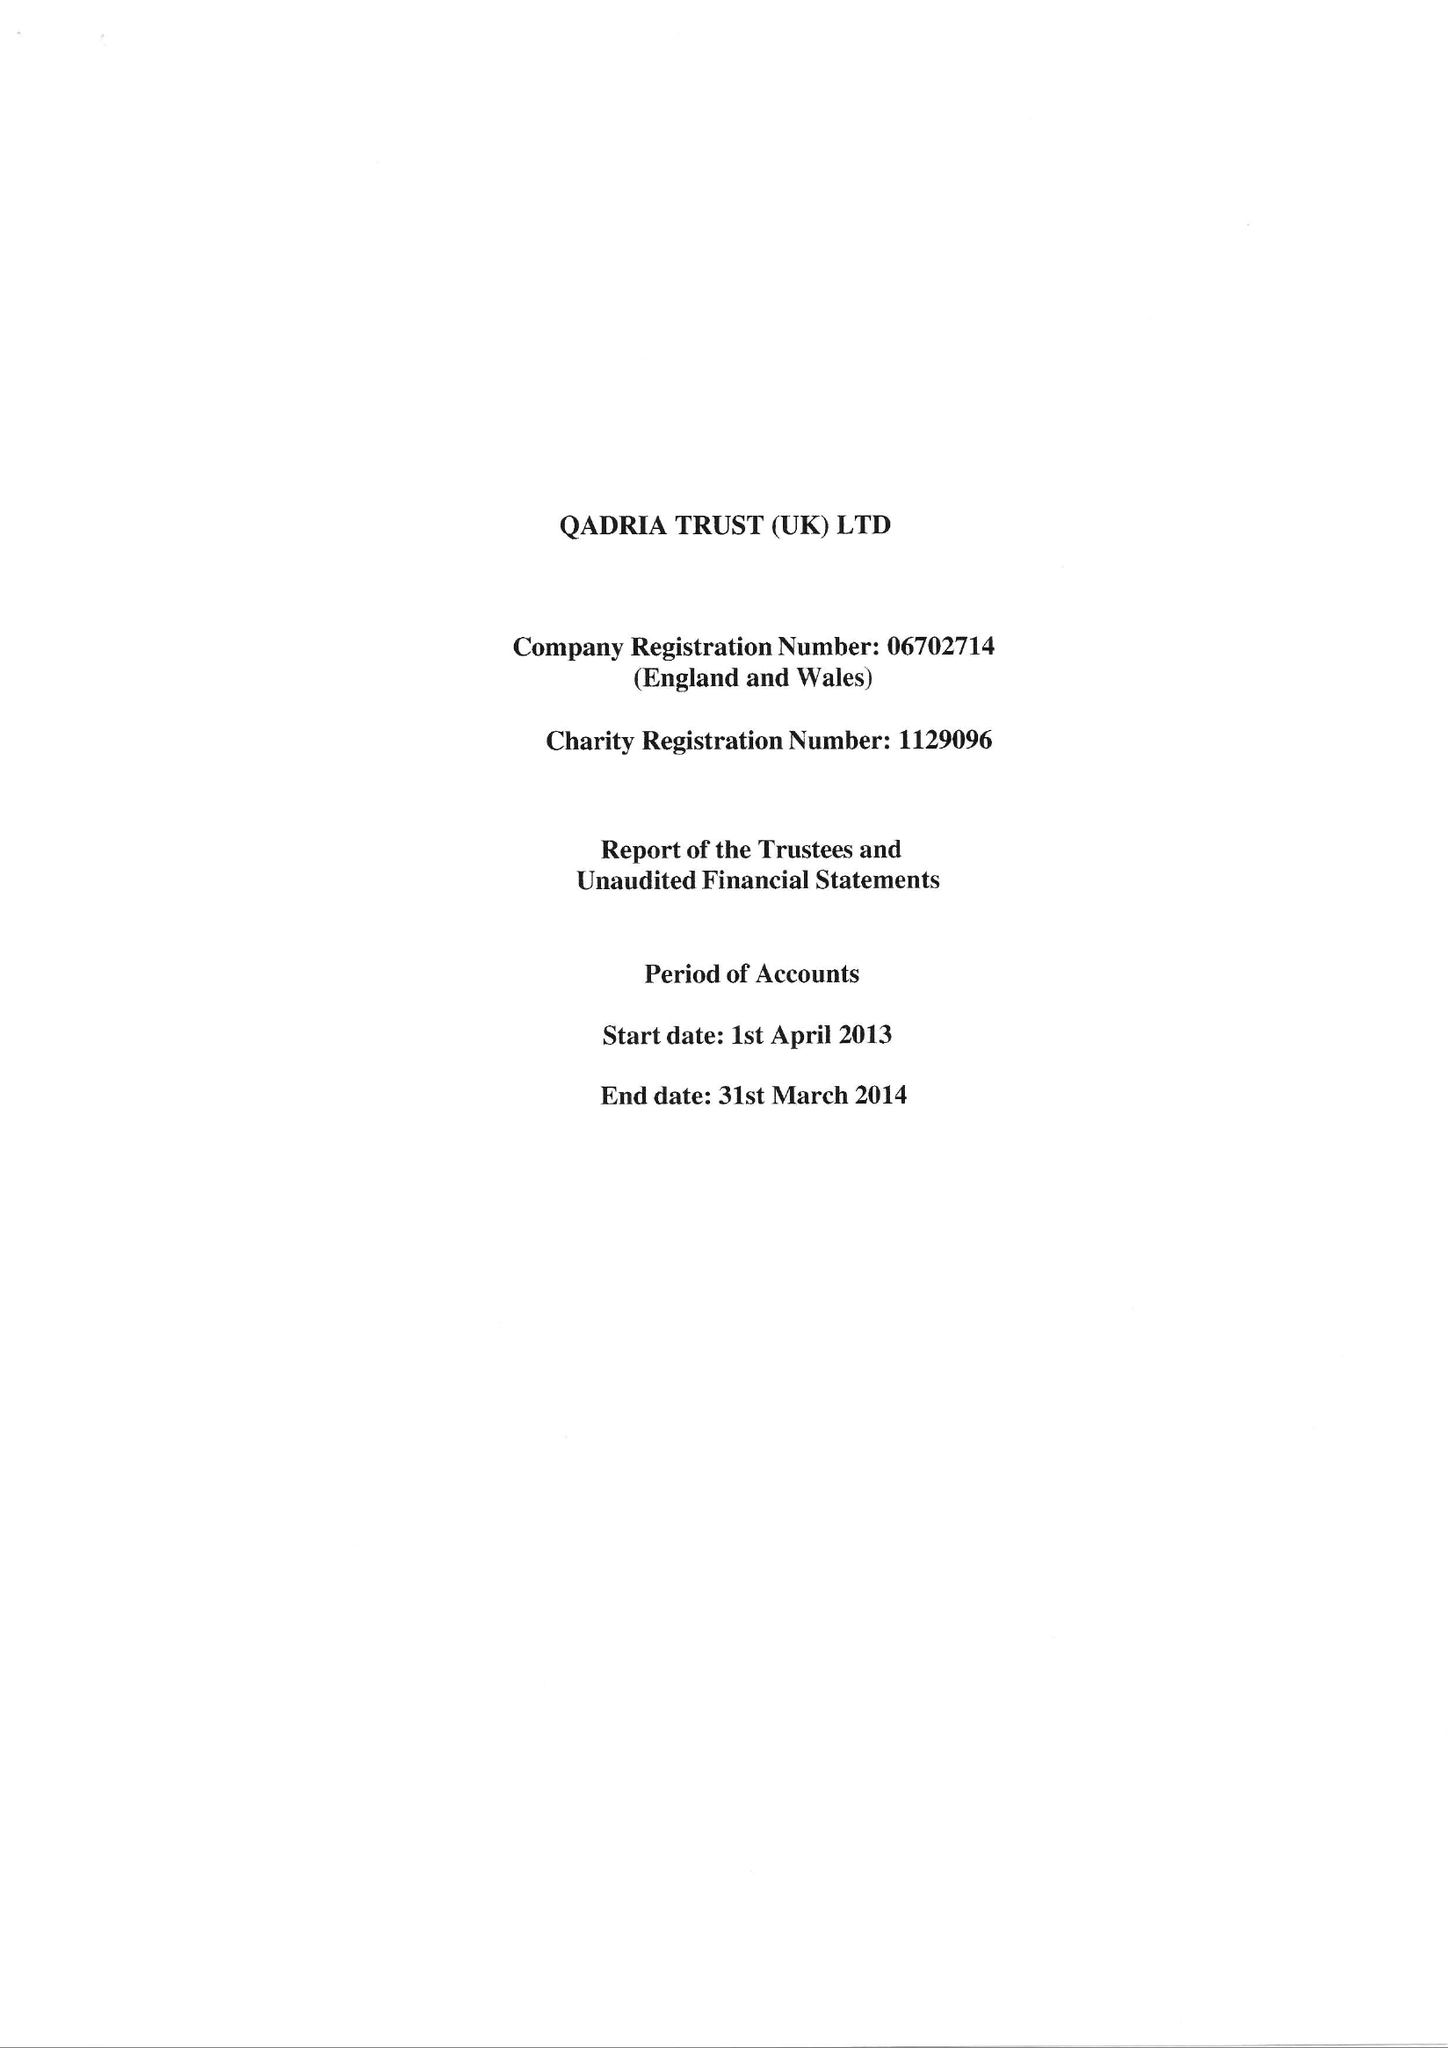What is the value for the charity_name?
Answer the question using a single word or phrase. Qadria Trust (Uk) 